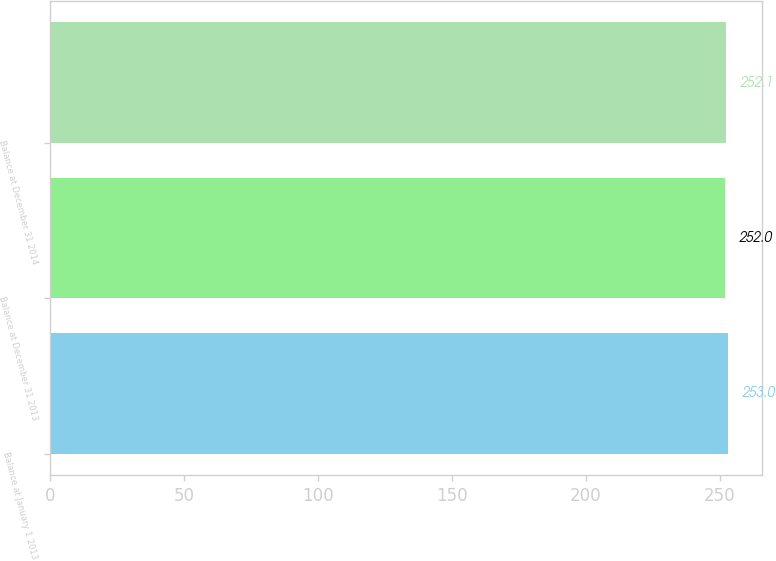Convert chart. <chart><loc_0><loc_0><loc_500><loc_500><bar_chart><fcel>Balance at January 1 2013<fcel>Balance at December 31 2013<fcel>Balance at December 31 2014<nl><fcel>253<fcel>252<fcel>252.1<nl></chart> 